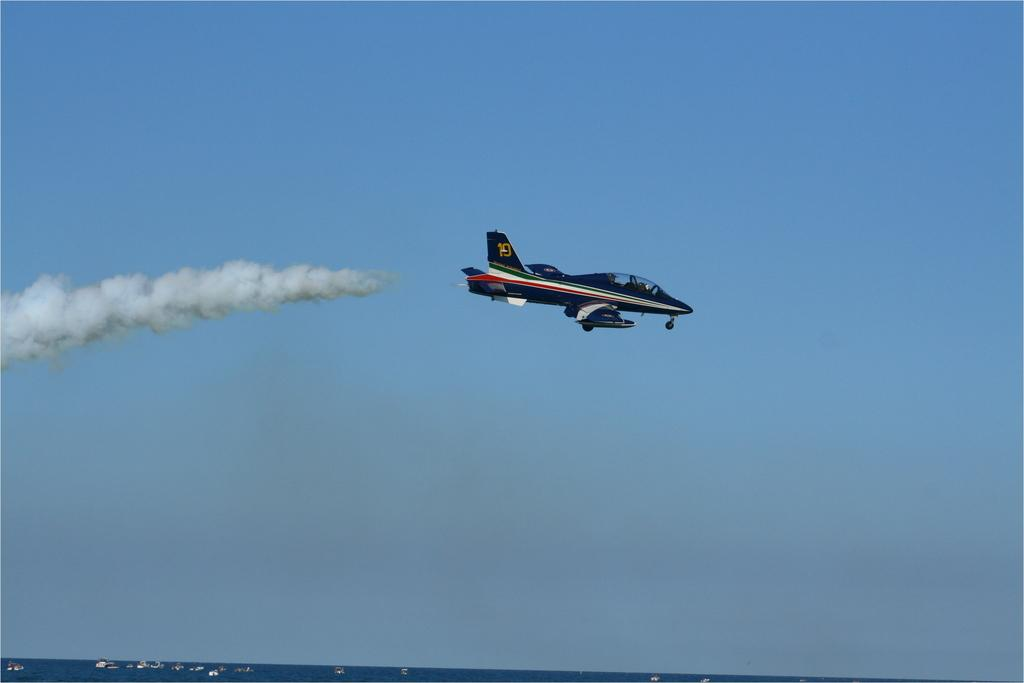<image>
Summarize the visual content of the image. A black jet is flying in a blue sky with the tail number 19. 